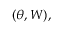Convert formula to latex. <formula><loc_0><loc_0><loc_500><loc_500>( \theta , W ) ,</formula> 